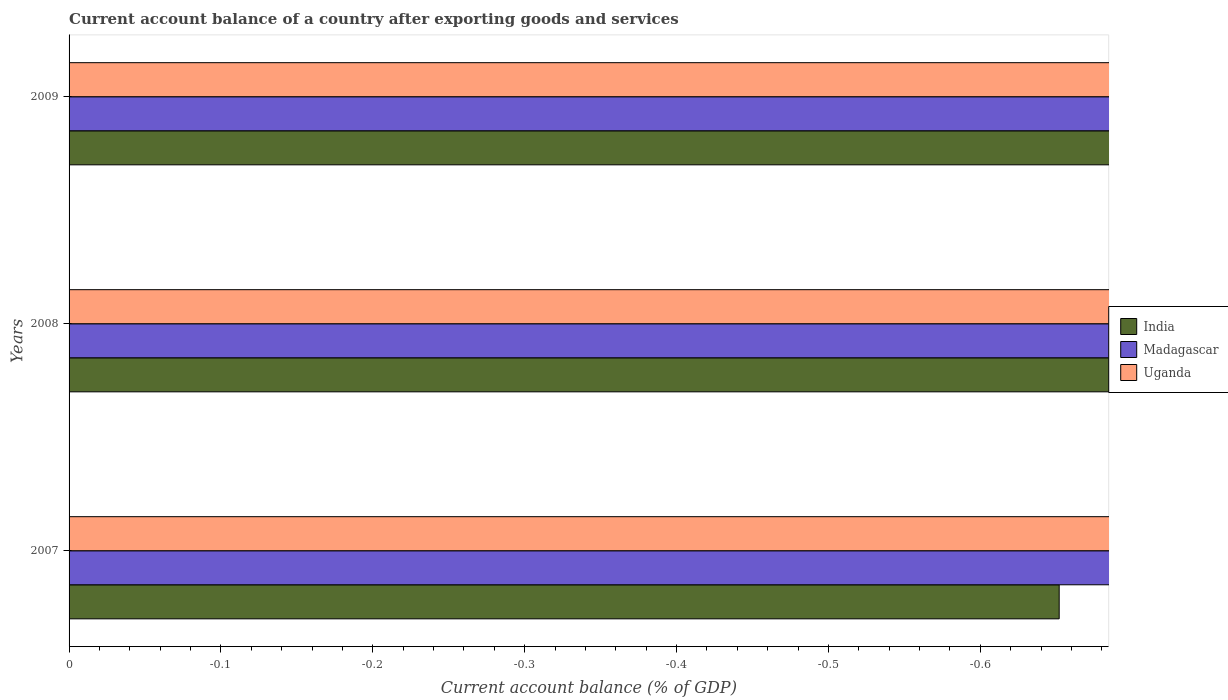How many different coloured bars are there?
Offer a terse response. 0. Are the number of bars per tick equal to the number of legend labels?
Offer a terse response. No. Are the number of bars on each tick of the Y-axis equal?
Your answer should be compact. Yes. How many bars are there on the 3rd tick from the top?
Give a very brief answer. 0. What is the account balance in India in 2009?
Make the answer very short. 0. Across all years, what is the minimum account balance in Uganda?
Make the answer very short. 0. What is the total account balance in Uganda in the graph?
Offer a terse response. 0. What is the difference between the account balance in India in 2009 and the account balance in Uganda in 2007?
Give a very brief answer. 0. In how many years, is the account balance in India greater than the average account balance in India taken over all years?
Keep it short and to the point. 0. Are all the bars in the graph horizontal?
Your answer should be compact. Yes. How many years are there in the graph?
Keep it short and to the point. 3. What is the difference between two consecutive major ticks on the X-axis?
Ensure brevity in your answer.  0.1. Does the graph contain any zero values?
Keep it short and to the point. Yes. What is the title of the graph?
Offer a terse response. Current account balance of a country after exporting goods and services. What is the label or title of the X-axis?
Offer a very short reply. Current account balance (% of GDP). What is the label or title of the Y-axis?
Give a very brief answer. Years. What is the Current account balance (% of GDP) in Uganda in 2007?
Your answer should be compact. 0. What is the Current account balance (% of GDP) of Madagascar in 2008?
Your answer should be very brief. 0. What is the Current account balance (% of GDP) of Uganda in 2008?
Your answer should be compact. 0. What is the total Current account balance (% of GDP) of Madagascar in the graph?
Your answer should be compact. 0. What is the average Current account balance (% of GDP) of India per year?
Provide a short and direct response. 0. What is the average Current account balance (% of GDP) of Uganda per year?
Give a very brief answer. 0. 